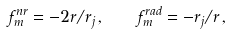<formula> <loc_0><loc_0><loc_500><loc_500>f ^ { n r } _ { m } = - 2 r / r _ { j } \, , \quad f ^ { r a d } _ { m } = - r _ { j } / r \, ,</formula> 